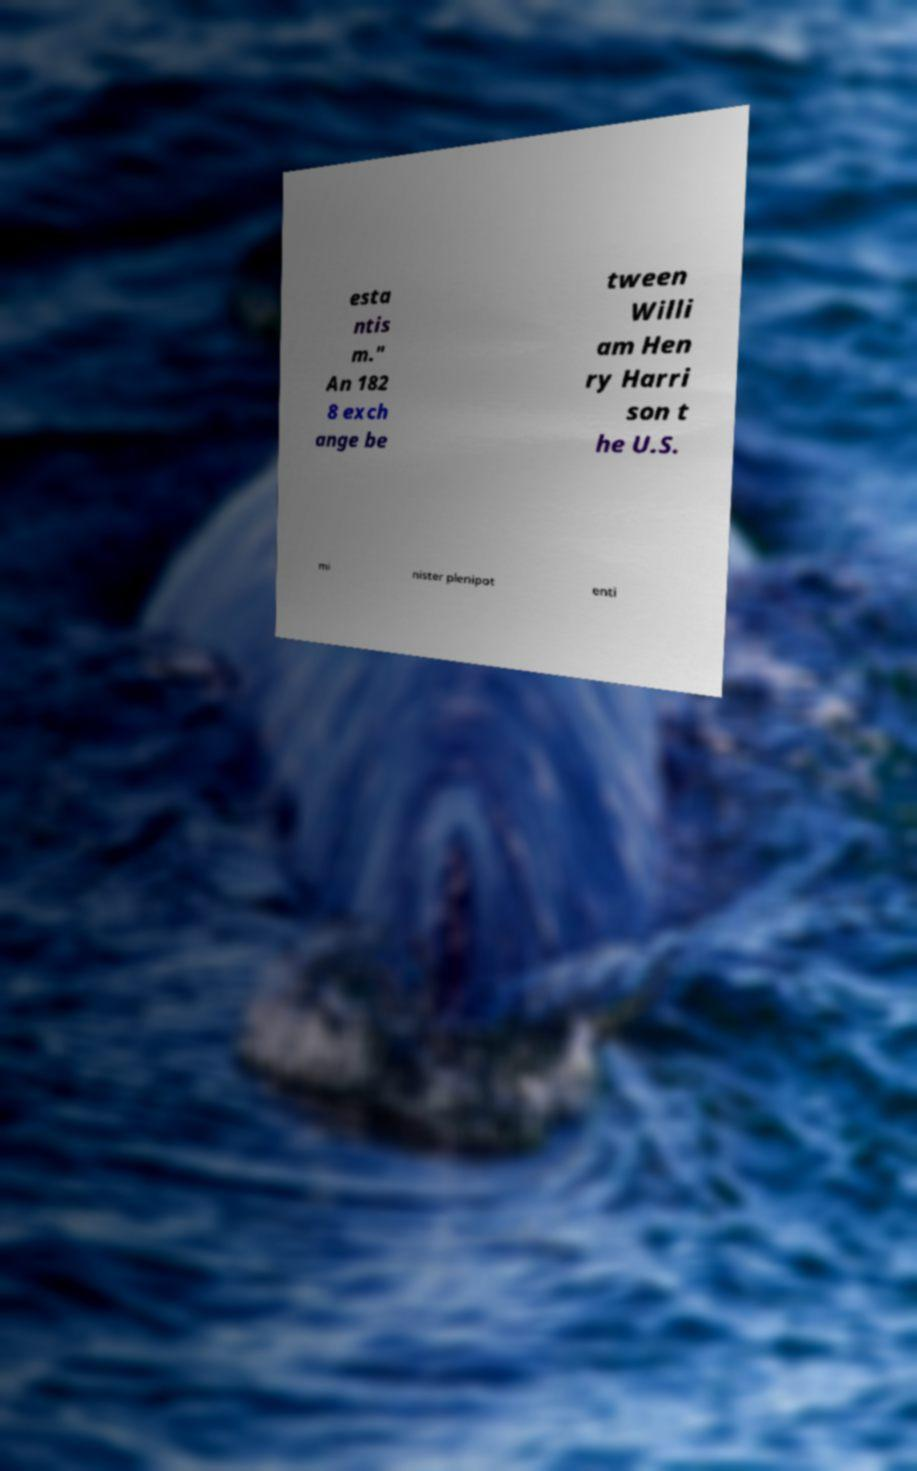Could you extract and type out the text from this image? esta ntis m." An 182 8 exch ange be tween Willi am Hen ry Harri son t he U.S. mi nister plenipot enti 